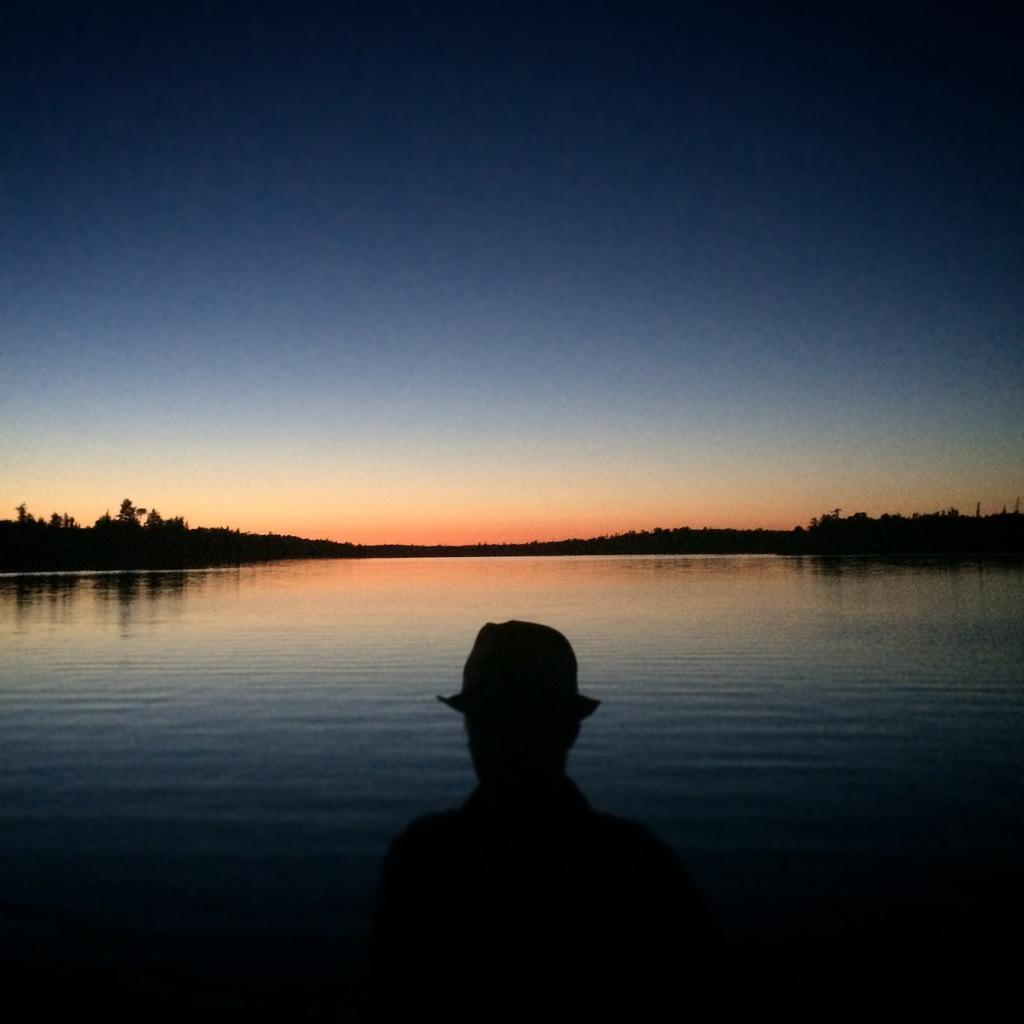In one or two sentences, can you explain what this image depicts? At the bottom of this image we can see a person. Here we can see water and trees. In the background there is sky. 